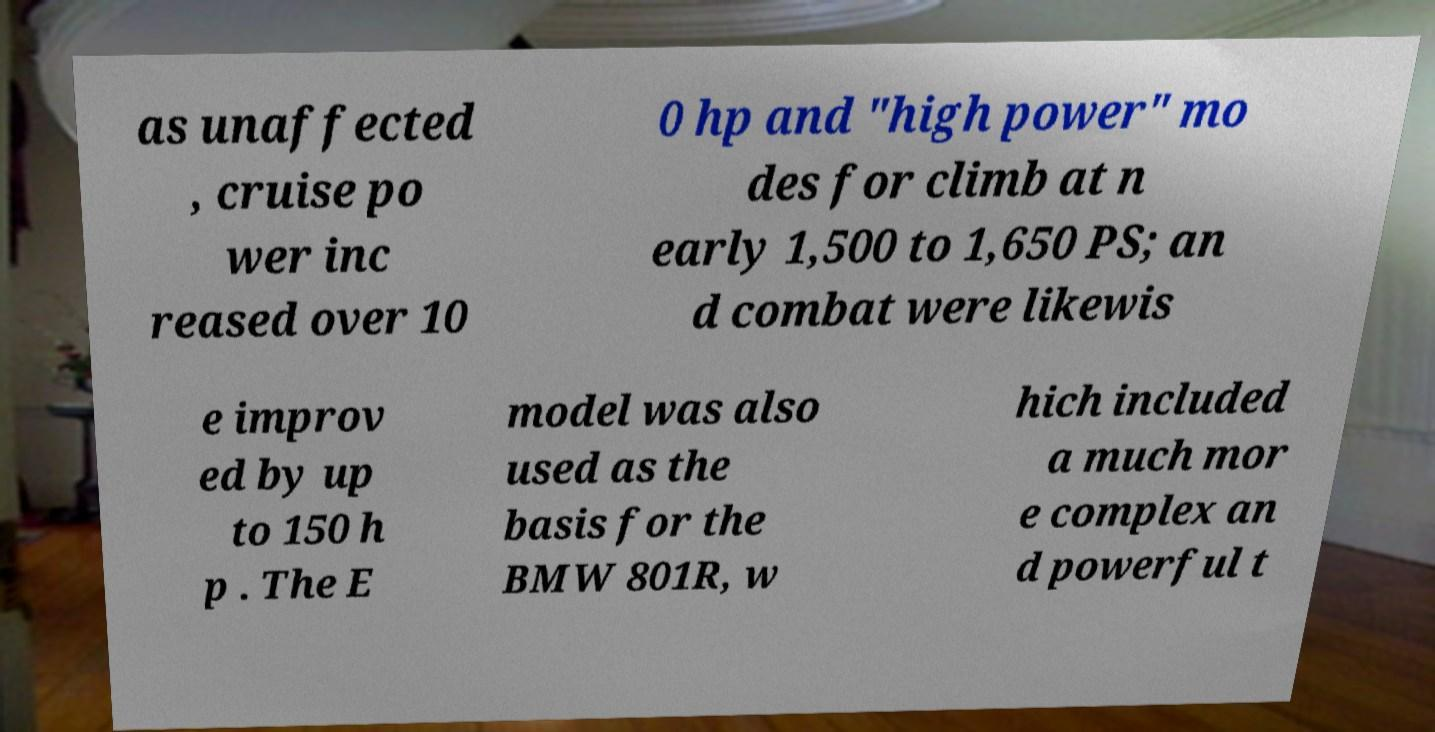Could you assist in decoding the text presented in this image and type it out clearly? as unaffected , cruise po wer inc reased over 10 0 hp and "high power" mo des for climb at n early 1,500 to 1,650 PS; an d combat were likewis e improv ed by up to 150 h p . The E model was also used as the basis for the BMW 801R, w hich included a much mor e complex an d powerful t 